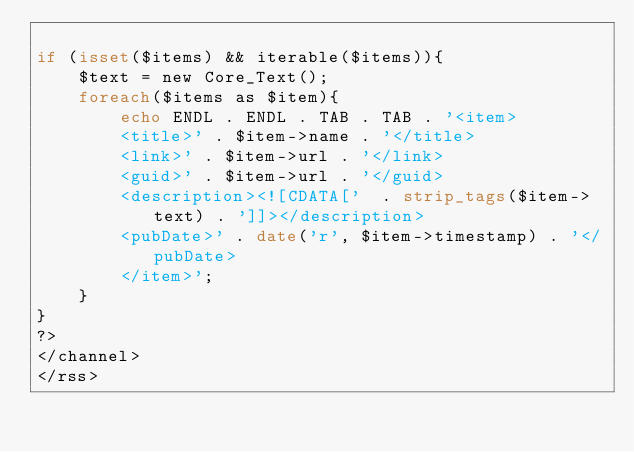Convert code to text. <code><loc_0><loc_0><loc_500><loc_500><_PHP_>
if (isset($items) && iterable($items)){
	$text = new Core_Text();
	foreach($items as $item){
		echo ENDL . ENDL . TAB . TAB . '<item>
		<title>' . $item->name . '</title>
		<link>' . $item->url . '</link>
		<guid>' . $item->url . '</guid>
		<description><![CDATA['  . strip_tags($item->text) . ']]></description>
		<pubDate>' . date('r', $item->timestamp) . '</pubDate>
		</item>';
	}
}
?>
</channel>
</rss>
</code> 